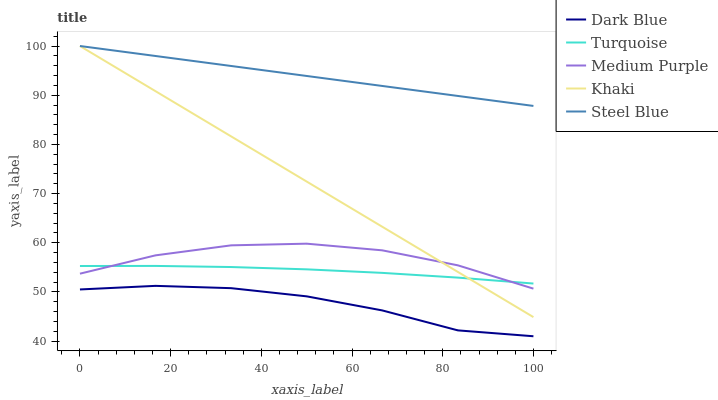Does Dark Blue have the minimum area under the curve?
Answer yes or no. Yes. Does Steel Blue have the maximum area under the curve?
Answer yes or no. Yes. Does Turquoise have the minimum area under the curve?
Answer yes or no. No. Does Turquoise have the maximum area under the curve?
Answer yes or no. No. Is Steel Blue the smoothest?
Answer yes or no. Yes. Is Medium Purple the roughest?
Answer yes or no. Yes. Is Dark Blue the smoothest?
Answer yes or no. No. Is Dark Blue the roughest?
Answer yes or no. No. Does Dark Blue have the lowest value?
Answer yes or no. Yes. Does Turquoise have the lowest value?
Answer yes or no. No. Does Steel Blue have the highest value?
Answer yes or no. Yes. Does Turquoise have the highest value?
Answer yes or no. No. Is Medium Purple less than Steel Blue?
Answer yes or no. Yes. Is Khaki greater than Dark Blue?
Answer yes or no. Yes. Does Turquoise intersect Khaki?
Answer yes or no. Yes. Is Turquoise less than Khaki?
Answer yes or no. No. Is Turquoise greater than Khaki?
Answer yes or no. No. Does Medium Purple intersect Steel Blue?
Answer yes or no. No. 